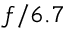<formula> <loc_0><loc_0><loc_500><loc_500>f / 6 . 7</formula> 